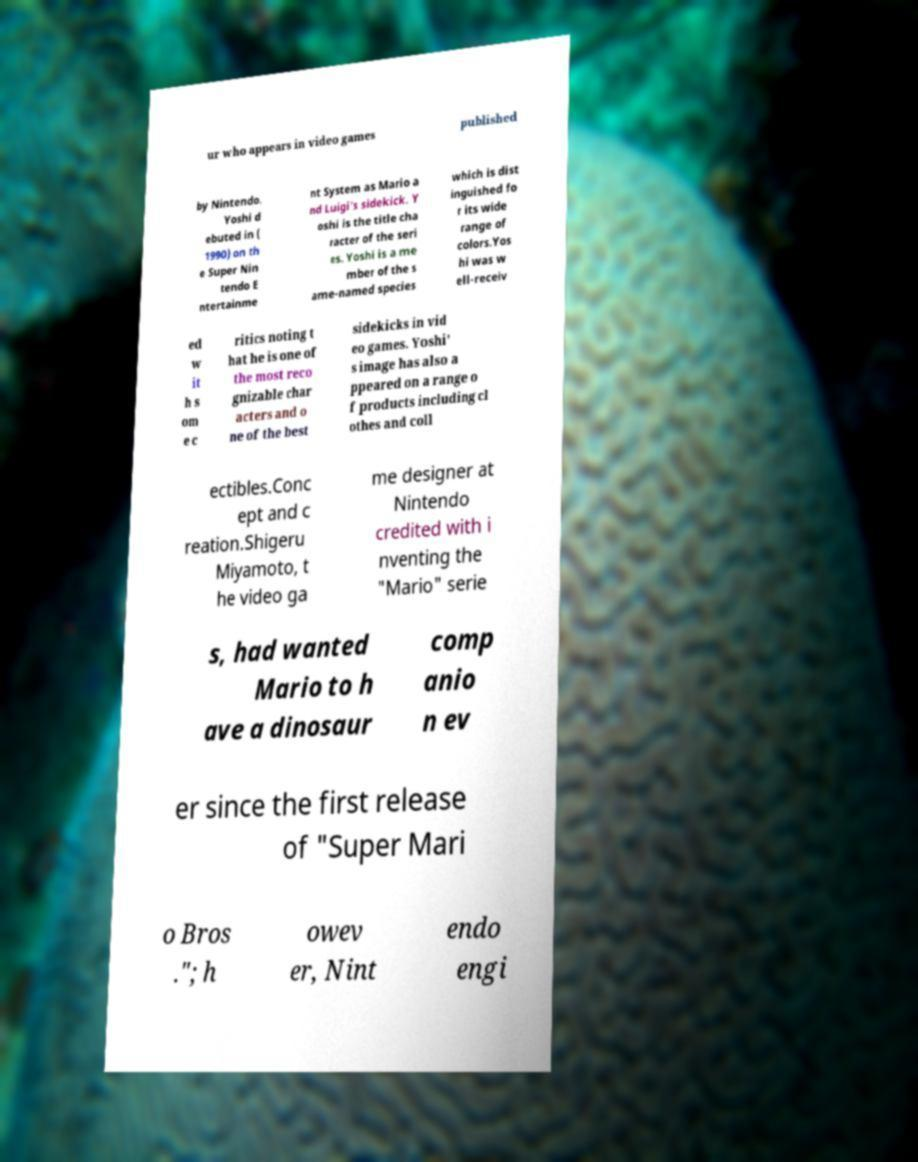Could you extract and type out the text from this image? ur who appears in video games published by Nintendo. Yoshi d ebuted in ( 1990) on th e Super Nin tendo E ntertainme nt System as Mario a nd Luigi's sidekick. Y oshi is the title cha racter of the seri es. Yoshi is a me mber of the s ame-named species which is dist inguished fo r its wide range of colors.Yos hi was w ell-receiv ed w it h s om e c ritics noting t hat he is one of the most reco gnizable char acters and o ne of the best sidekicks in vid eo games. Yoshi' s image has also a ppeared on a range o f products including cl othes and coll ectibles.Conc ept and c reation.Shigeru Miyamoto, t he video ga me designer at Nintendo credited with i nventing the "Mario" serie s, had wanted Mario to h ave a dinosaur comp anio n ev er since the first release of "Super Mari o Bros ."; h owev er, Nint endo engi 